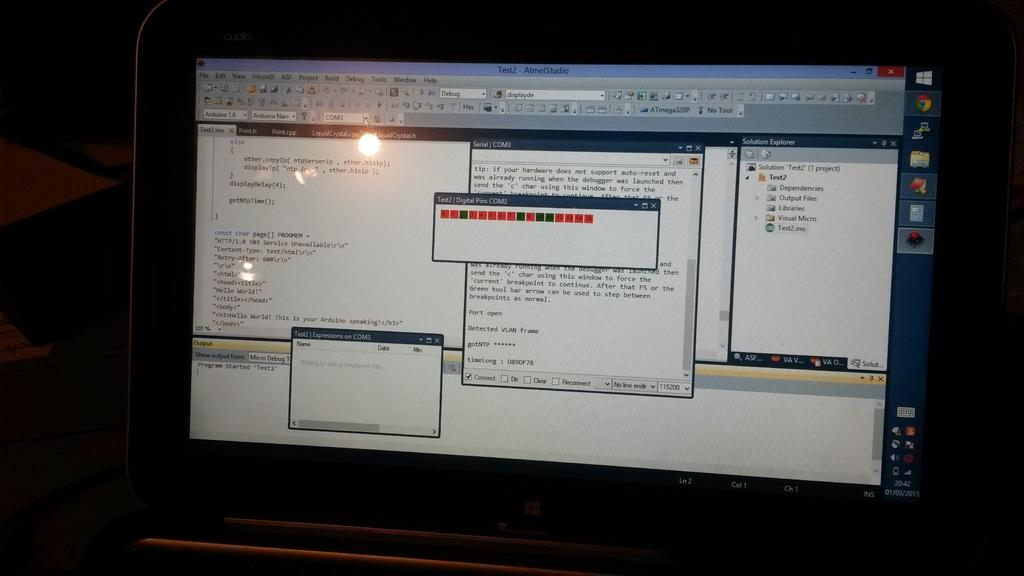What is the main object in the image? There is a screen in the image. What color is the background of the image? The background of the image is black. Can you see a list of items on the screen in the image? There is no information about the content of the screen in the image, so it cannot be determined if there is a list of items. 